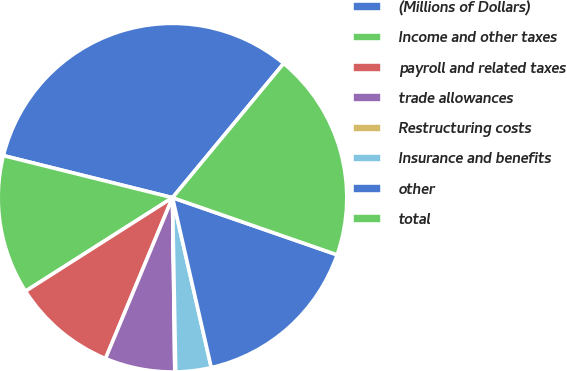Convert chart to OTSL. <chart><loc_0><loc_0><loc_500><loc_500><pie_chart><fcel>(Millions of Dollars)<fcel>Income and other taxes<fcel>payroll and related taxes<fcel>trade allowances<fcel>Restructuring costs<fcel>Insurance and benefits<fcel>other<fcel>total<nl><fcel>32.13%<fcel>12.9%<fcel>9.7%<fcel>6.49%<fcel>0.08%<fcel>3.28%<fcel>16.11%<fcel>19.31%<nl></chart> 